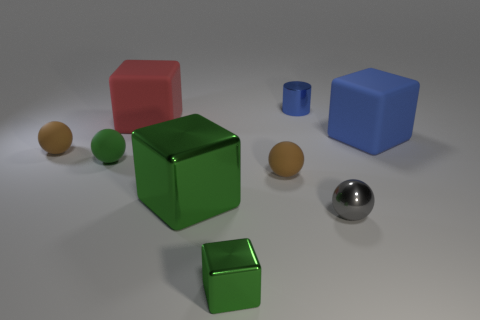Can you tell me how many spheres are present, and what their colors are? There are three spheres in the image. Two of them have a muted brown tone, suggesting a wooden material, and one sphere has a shiny metallic surface. 